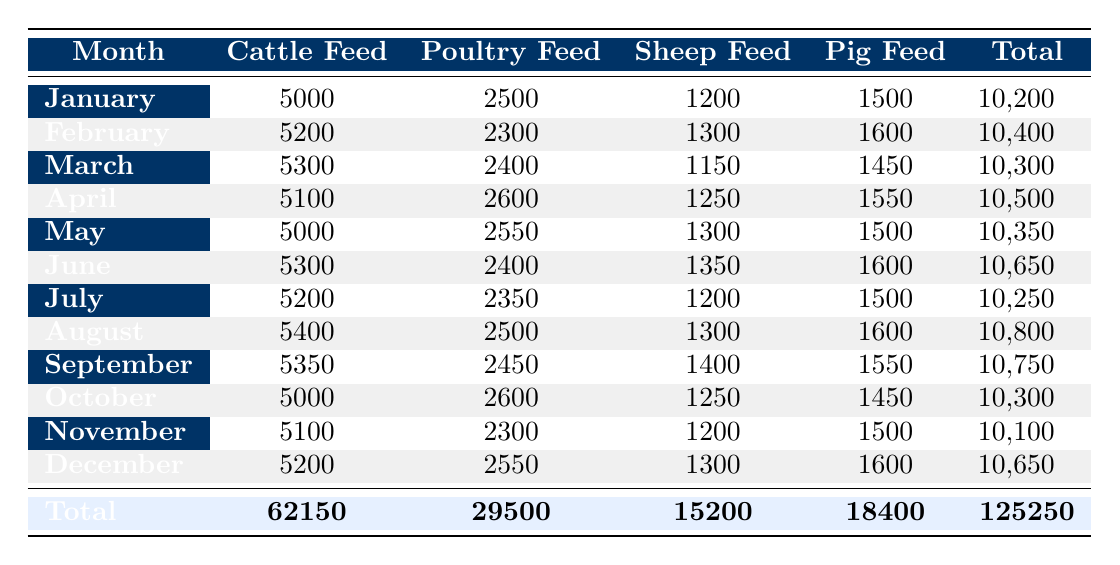What was the total expenditure on poultry feed in July? The table shows that in July, the expenditure on poultry feed is 2350. Therefore, the total expenditure on poultry feed in July is 2350.
Answer: 2350 Which month had the highest expenditure on cattle feed? By reviewing the table, August shows the highest expenditure on cattle feed at 5400. Thus, August had the highest expenditure on cattle feed.
Answer: August What is the total expenditure across all months for sheep feed? To find the total expenditure for sheep feed, we add up the values from each month: 1200 + 1300 + 1150 + 1250 + 1300 + 1350 + 1200 + 1300 + 1400 + 1250 + 1200 + 1300 = 15200. So, the total expenditure for sheep feed is 15200.
Answer: 15200 Was the total expenditure on animal feeds higher in the first half of the year compared to the second half? To determine this, we need to calculate the total expenditure for both halves. The first half (January to June) totals 10200 + 10400 + 10300 + 10500 + 10350 + 10650 = 63000. The second half (July to December) totals 10250 + 10800 + 10750 + 10300 + 10100 + 10650 = 62850. Thus, the first half had higher total expenditure, confirming the statement is true.
Answer: Yes What was the average expenditure on pig feed over the year? The pig feed expenditure for each month is 1500, 1600, 1450, 1550, 1500, 1600, 1500, 1600, 1550, 1450, 1500, and 1600. First, we sum these values: 1500 + 1600 + 1450 + 1550 + 1500 + 1600 + 1500 + 1600 + 1550 + 1450 + 1500 + 1600 = 18400. There are 12 months, so we calculate the average: 18400 / 12 = 1533.33. Hence, the average expenditure on pig feed is approximately 1533.33.
Answer: 1533.33 